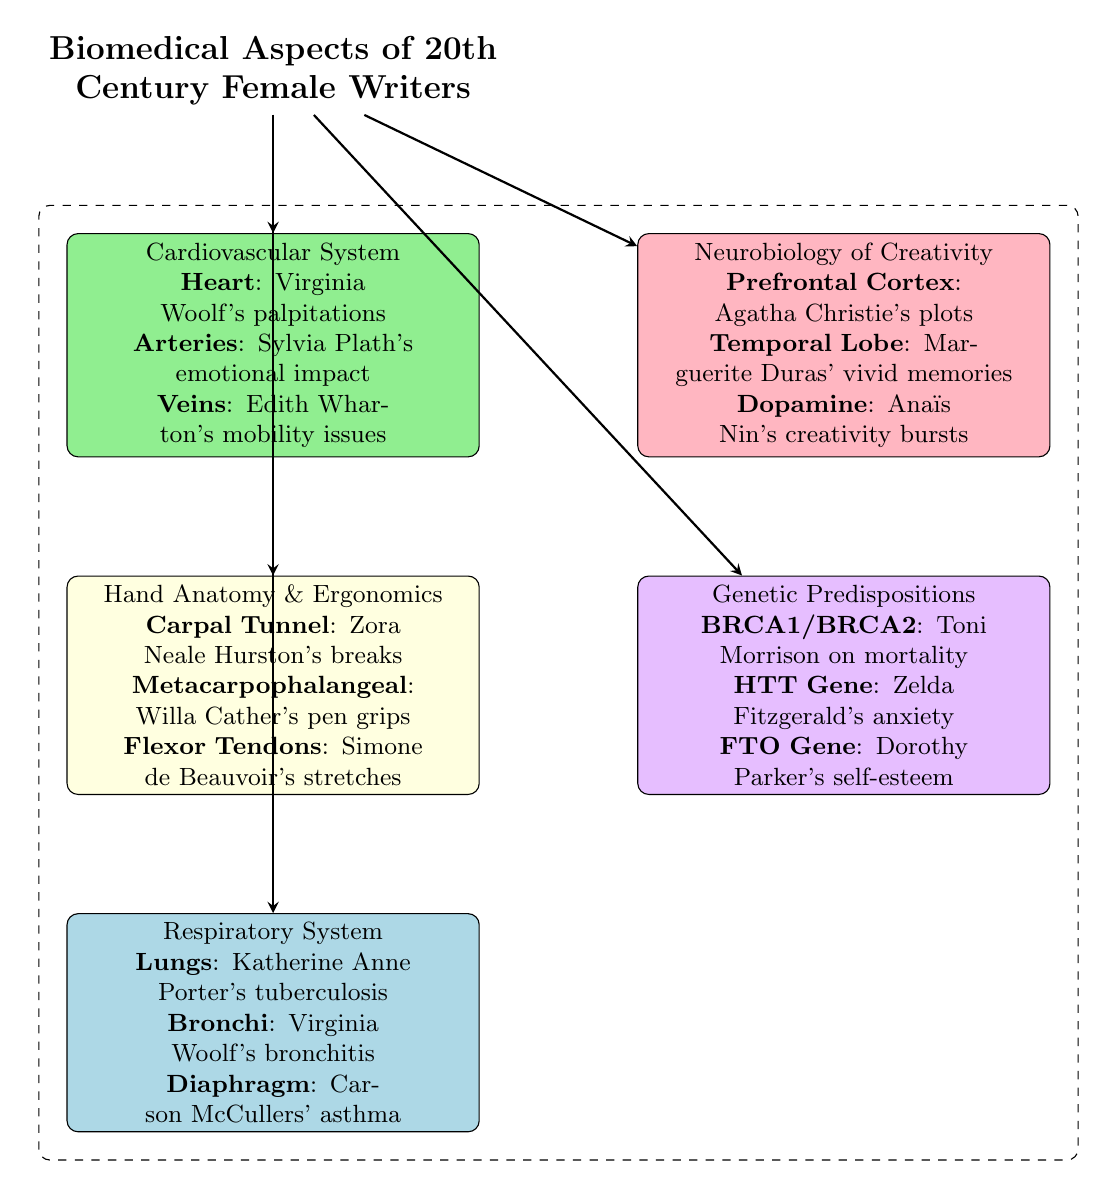What component is associated with Virginia Woolf in the cardiovascular system? The diagram indicates that Virginia Woolf is associated with "Heart" which represents her palpitations. This information is specifically located in the section detailing the cardiovascular system.
Answer: Heart Which writer is linked to asthma in the respiratory system section? The diagram describes "Carson McCullers" in relation to asthma under the respiratory system, indicating how this condition affected her writing. This connection is explicitly mentioned in the respiratory system box.
Answer: Carson McCullers How many major boxes are present in the diagram? The diagram contains five major boxes, each representing different biomedical aspects related to female writers of the 20th century: cardiovascular system, neurobiology of creativity, hand anatomy & ergonomics, genetic predispositions, and respiratory system. Counting these boxes confirms there are five.
Answer: Five What is indicated about Toni Morrison's genetic predisposition? The diagram suggests that Toni Morrison is linked to "BRCA1/BRCA2" in the genetic predispositions section, which implies her experience with mortality related to this genetic marker. This information is located in the corresponding genetic predispositions box.
Answer: BRCA1/BRCA2 What brain region is associated with Agatha Christie's plots? According to the neurobiology of creativity section of the diagram, Agatha Christie's plots are specifically associated with the "Prefrontal Cortex," which reflects her creative processes. This connection is explicitly noted in the neurobiology of creativity box.
Answer: Prefrontal Cortex Which author faced mobility issues as described in the cardiovascular system? The cardiovascular system box highlights "Edith Wharton's mobility issues," indicating a direct link to her experiences related to the cardiovascular system. This mention is clear in the context of the cardiovascular system box.
Answer: Edith Wharton How does the diagram illustrate the impact of respiratory conditions on female writers? The diagram illustrates the impact by discussing specific respiratory conditions like tuberculosis and asthma, linking them to Katherine Anne Porter and Carson McCullers respectively, indicating that these conditions affected their productivity and well-being. This understanding requires synthesizing the information presented in the respiratory system section.
Answer: Respiratory conditions What ergonomic issue is mentioned in connection with Zora Neale Hurston? The diagram mentions "Carpal Tunnel" as an ergonomic issue associated with Zora Neale Hurston, highlighting specific health struggles that may have impacted her writing. This information is clearly stated in the hand anatomy & ergonomics box.
Answer: Carpal Tunnel 